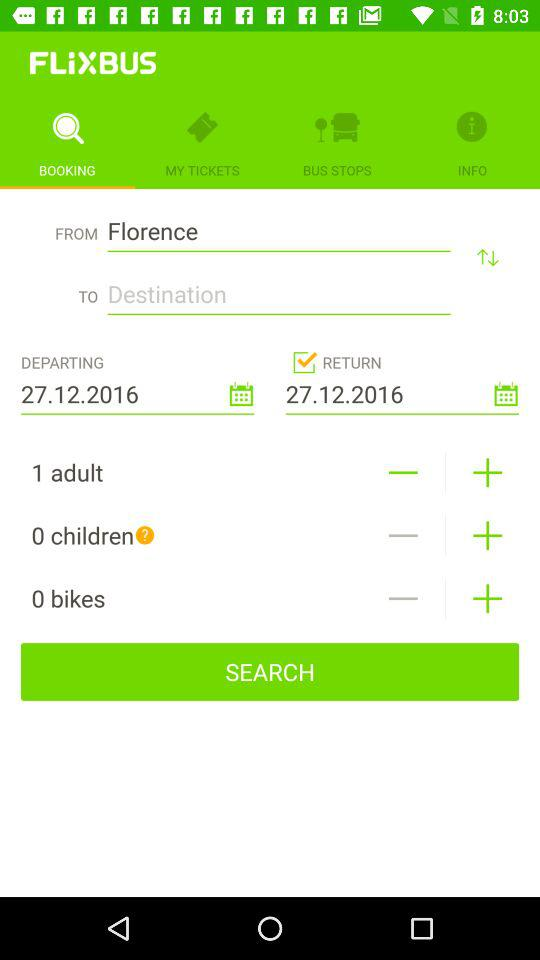What is the selected date of return? The selected date of return is December 27, 2016. 